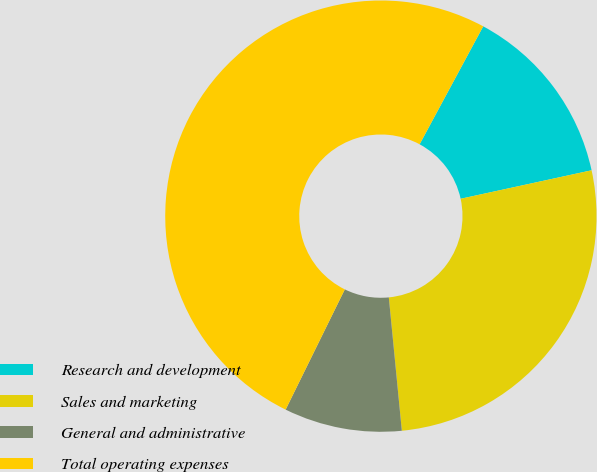Convert chart. <chart><loc_0><loc_0><loc_500><loc_500><pie_chart><fcel>Research and development<fcel>Sales and marketing<fcel>General and administrative<fcel>Total operating expenses<nl><fcel>13.72%<fcel>26.86%<fcel>8.83%<fcel>50.59%<nl></chart> 